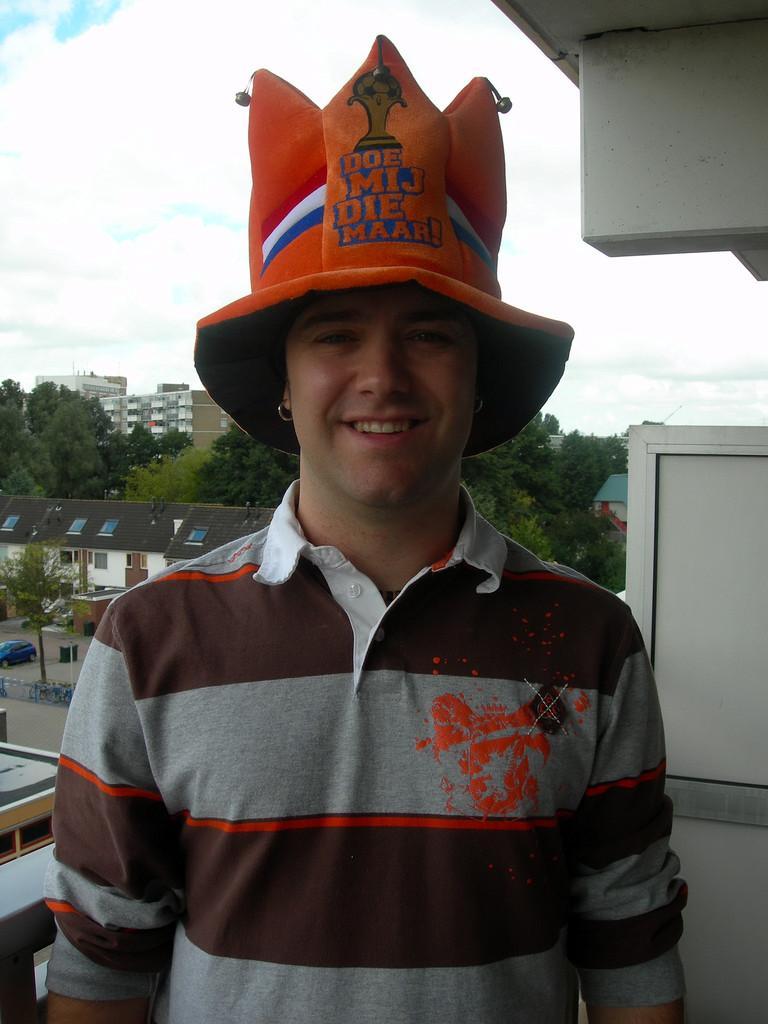Can you describe this image briefly? In the background we can see the clouds in the sky, buildings, trees, vehicles and objects. This picture is mainly highlighted with a man wearing a cap, t-shirt and he is smiling. On the right side of the picture we can see the wall. 